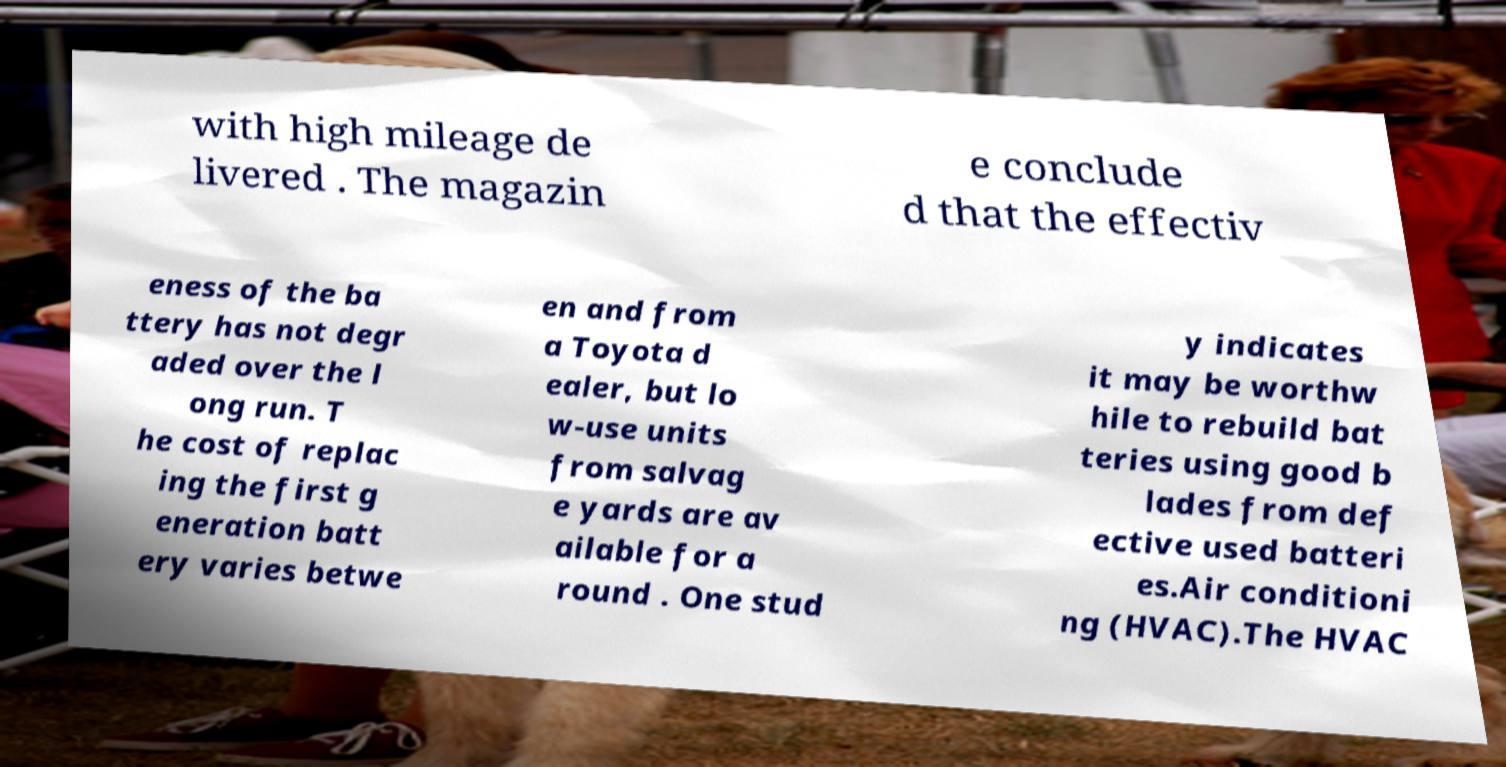What messages or text are displayed in this image? I need them in a readable, typed format. with high mileage de livered . The magazin e conclude d that the effectiv eness of the ba ttery has not degr aded over the l ong run. T he cost of replac ing the first g eneration batt ery varies betwe en and from a Toyota d ealer, but lo w-use units from salvag e yards are av ailable for a round . One stud y indicates it may be worthw hile to rebuild bat teries using good b lades from def ective used batteri es.Air conditioni ng (HVAC).The HVAC 